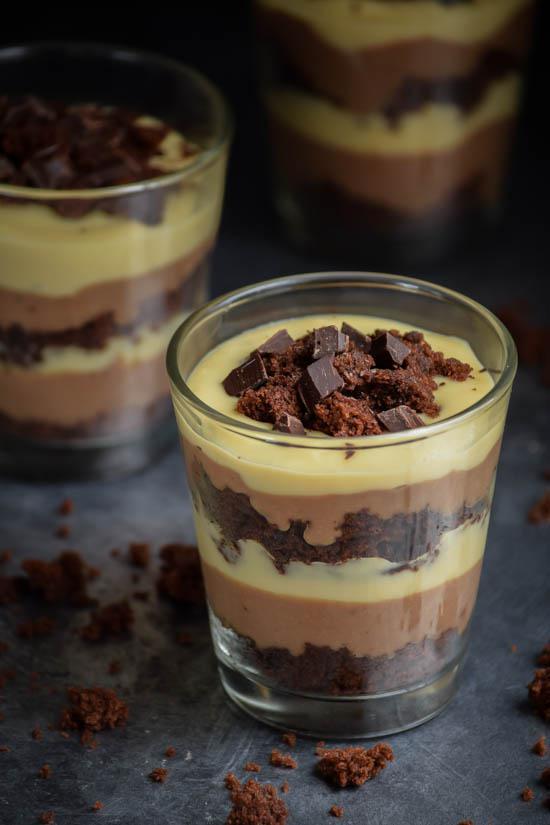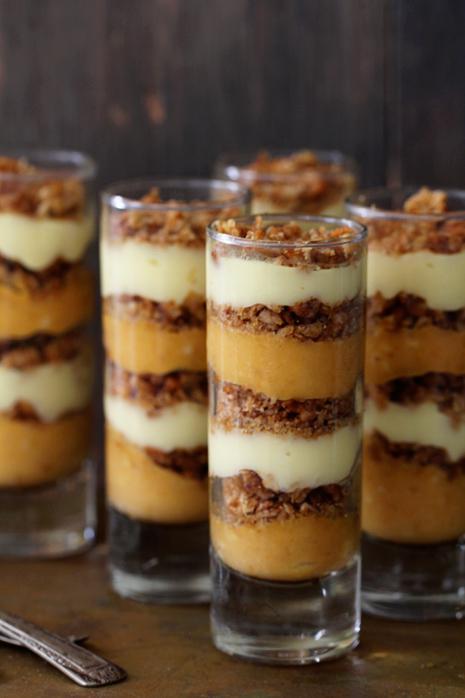The first image is the image on the left, the second image is the image on the right. Given the left and right images, does the statement "An image shows at least four individual layered desserts served in slender cylindrical glasses." hold true? Answer yes or no. Yes. The first image is the image on the left, the second image is the image on the right. Evaluate the accuracy of this statement regarding the images: "Each image shows at least three individual layered desserts, one at the front and others behind it, made in clear glasses with a garnished top.". Is it true? Answer yes or no. Yes. 